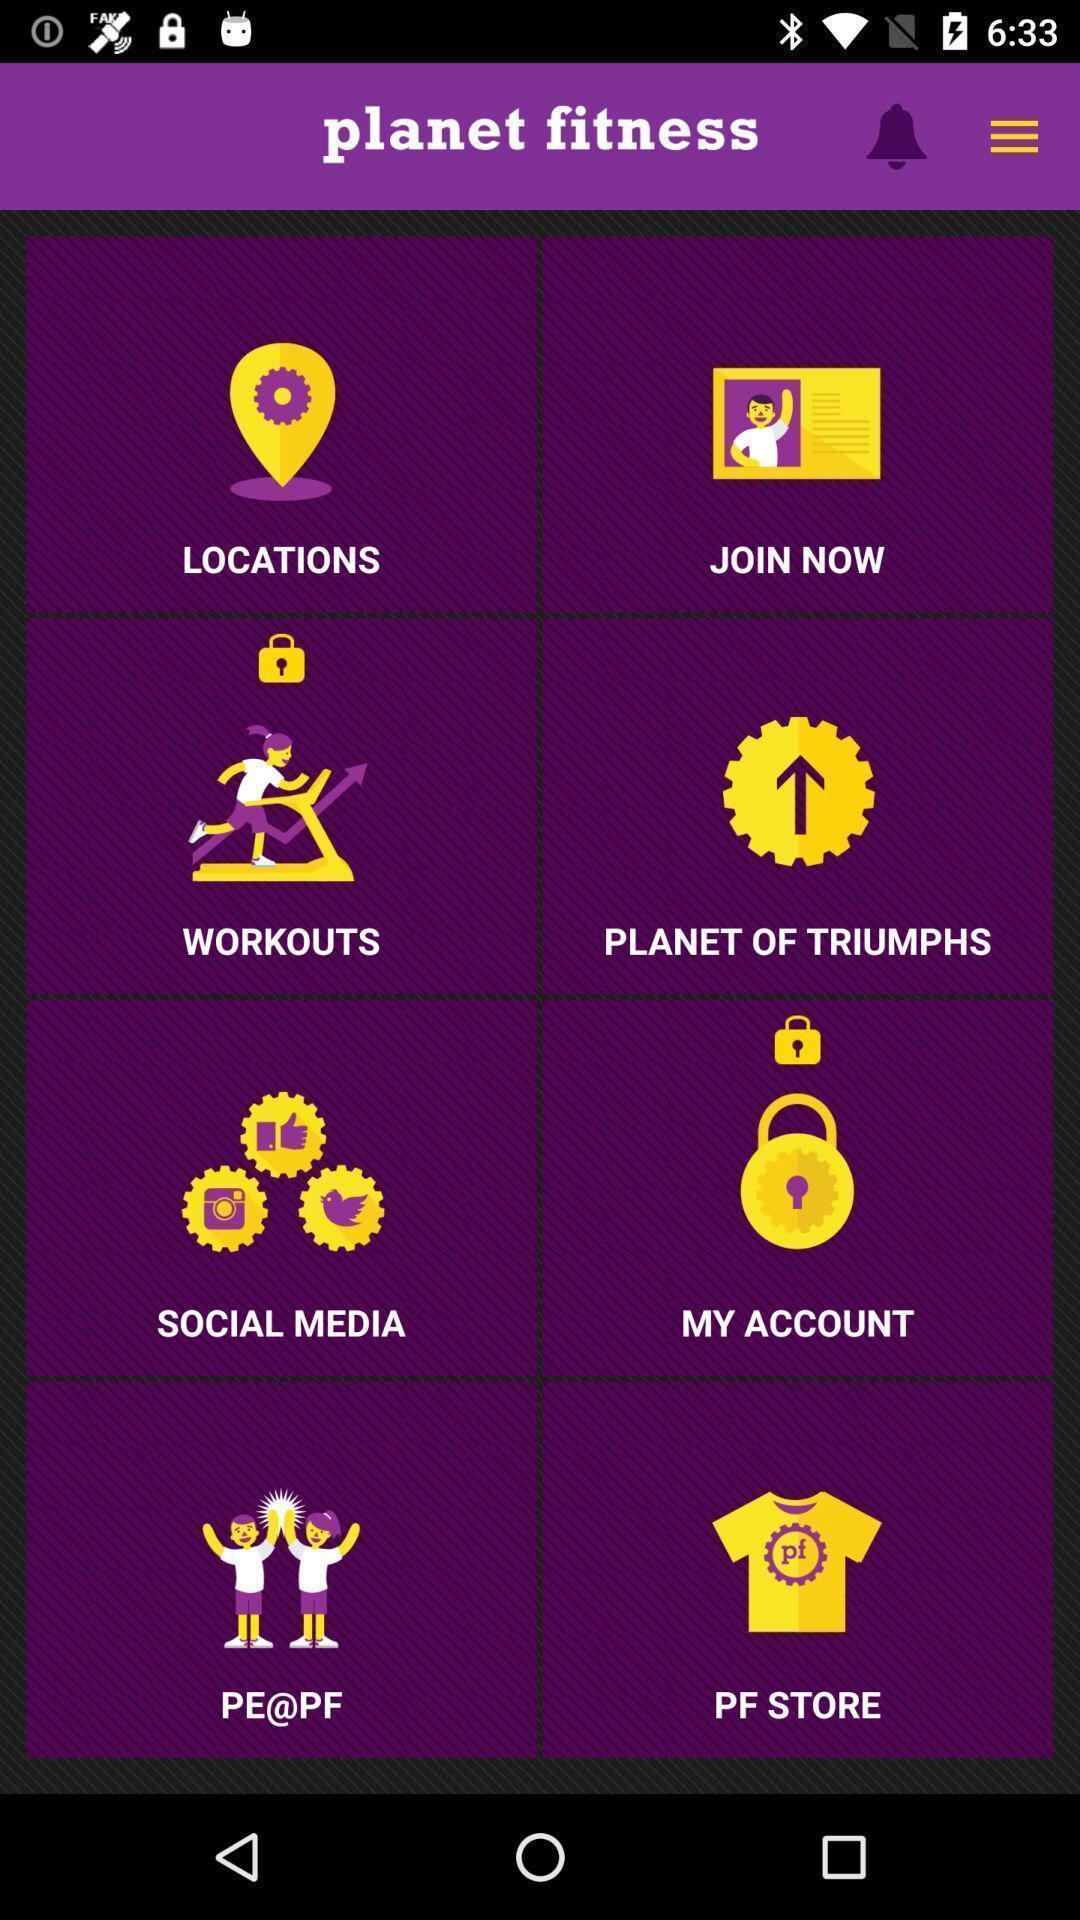What details can you identify in this image? Screen shows multiple options in a fitness application. 